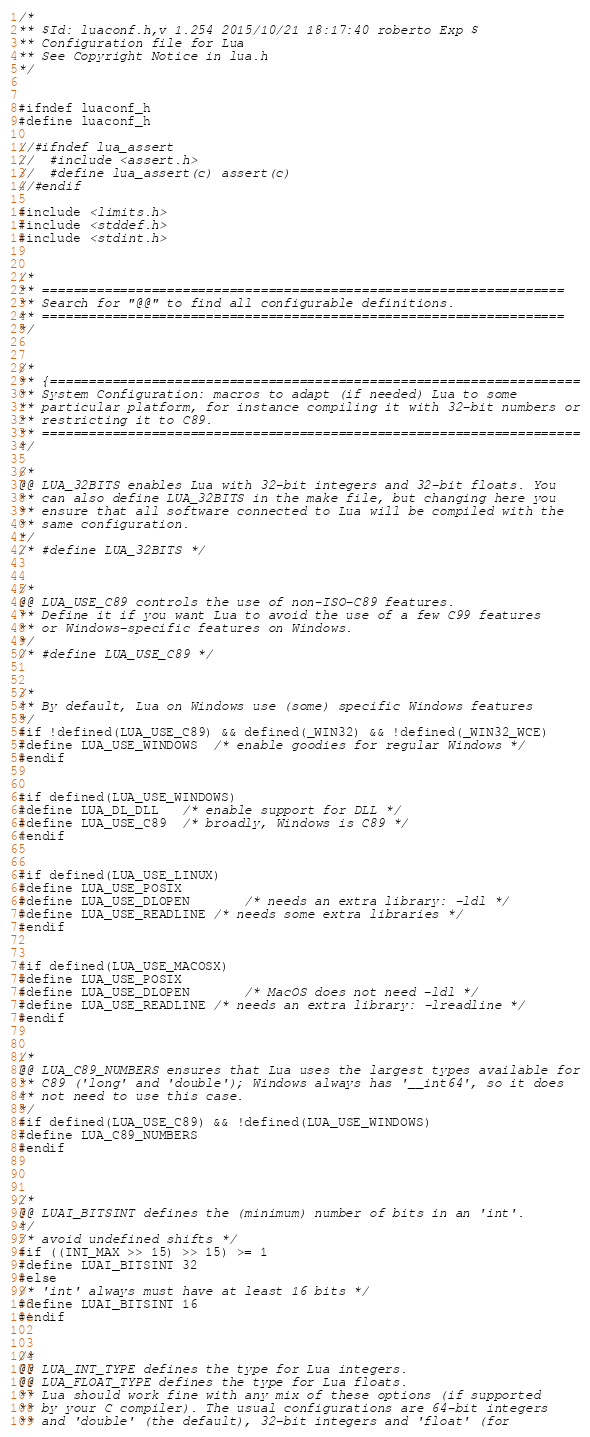<code> <loc_0><loc_0><loc_500><loc_500><_C_>/*
** $Id: luaconf.h,v 1.254 2015/10/21 18:17:40 roberto Exp $
** Configuration file for Lua
** See Copyright Notice in lua.h
*/


#ifndef luaconf_h
#define luaconf_h

//#ifndef lua_assert
//	#include <assert.h>
//	#define lua_assert(c) assert(c)
//#endif

#include <limits.h>
#include <stddef.h>
#include <stdint.h>


/*
** ===================================================================
** Search for "@@" to find all configurable definitions.
** ===================================================================
*/


/*
** {====================================================================
** System Configuration: macros to adapt (if needed) Lua to some
** particular platform, for instance compiling it with 32-bit numbers or
** restricting it to C89.
** =====================================================================
*/

/*
@@ LUA_32BITS enables Lua with 32-bit integers and 32-bit floats. You
** can also define LUA_32BITS in the make file, but changing here you
** ensure that all software connected to Lua will be compiled with the
** same configuration.
*/
/* #define LUA_32BITS */


/*
@@ LUA_USE_C89 controls the use of non-ISO-C89 features.
** Define it if you want Lua to avoid the use of a few C99 features
** or Windows-specific features on Windows.
*/
/* #define LUA_USE_C89 */


/*
** By default, Lua on Windows use (some) specific Windows features
*/
#if !defined(LUA_USE_C89) && defined(_WIN32) && !defined(_WIN32_WCE)
#define LUA_USE_WINDOWS  /* enable goodies for regular Windows */
#endif


#if defined(LUA_USE_WINDOWS)
#define LUA_DL_DLL	/* enable support for DLL */
#define LUA_USE_C89	/* broadly, Windows is C89 */
#endif


#if defined(LUA_USE_LINUX)
#define LUA_USE_POSIX
#define LUA_USE_DLOPEN		/* needs an extra library: -ldl */
#define LUA_USE_READLINE	/* needs some extra libraries */
#endif


#if defined(LUA_USE_MACOSX)
#define LUA_USE_POSIX
#define LUA_USE_DLOPEN		/* MacOS does not need -ldl */
#define LUA_USE_READLINE	/* needs an extra library: -lreadline */
#endif


/*
@@ LUA_C89_NUMBERS ensures that Lua uses the largest types available for
** C89 ('long' and 'double'); Windows always has '__int64', so it does
** not need to use this case.
*/
#if defined(LUA_USE_C89) && !defined(LUA_USE_WINDOWS)
#define LUA_C89_NUMBERS
#endif



/*
@@ LUAI_BITSINT defines the (minimum) number of bits in an 'int'.
*/
/* avoid undefined shifts */
#if ((INT_MAX >> 15) >> 15) >= 1
#define LUAI_BITSINT	32
#else
/* 'int' always must have at least 16 bits */
#define LUAI_BITSINT	16
#endif


/*
@@ LUA_INT_TYPE defines the type for Lua integers.
@@ LUA_FLOAT_TYPE defines the type for Lua floats.
** Lua should work fine with any mix of these options (if supported
** by your C compiler). The usual configurations are 64-bit integers
** and 'double' (the default), 32-bit integers and 'float' (for</code> 